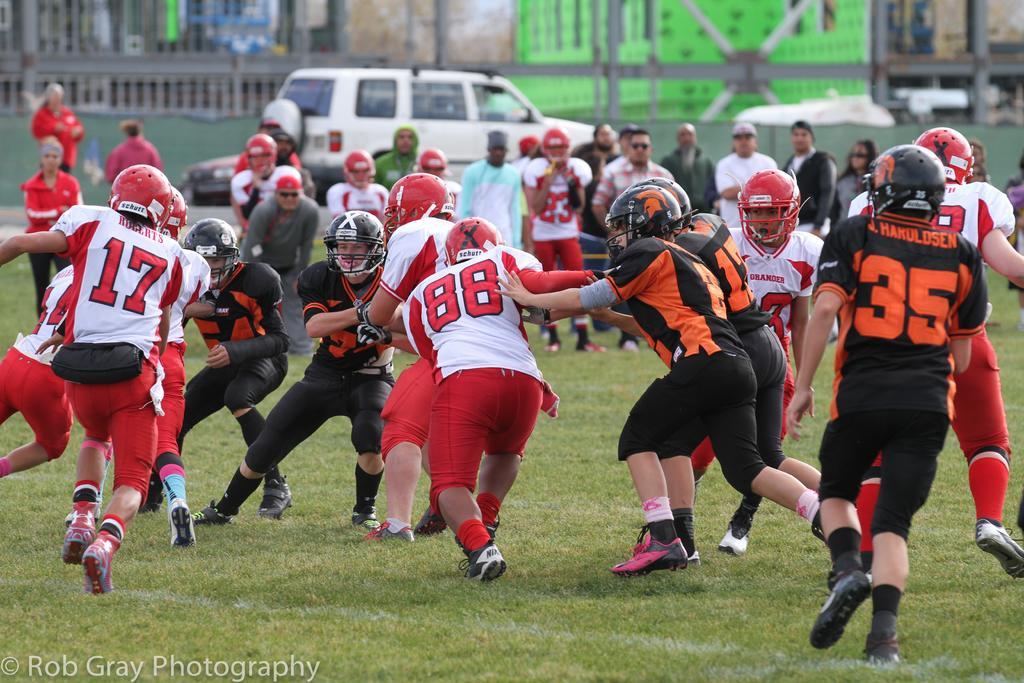How would you summarize this image in a sentence or two? In this image, we can see a group of people. Few are standing and running on the grass. At the bottom, we can see a watermark in the image. Background we can see vehicles, railing, walls, poles. Few people are wearing helmets. 